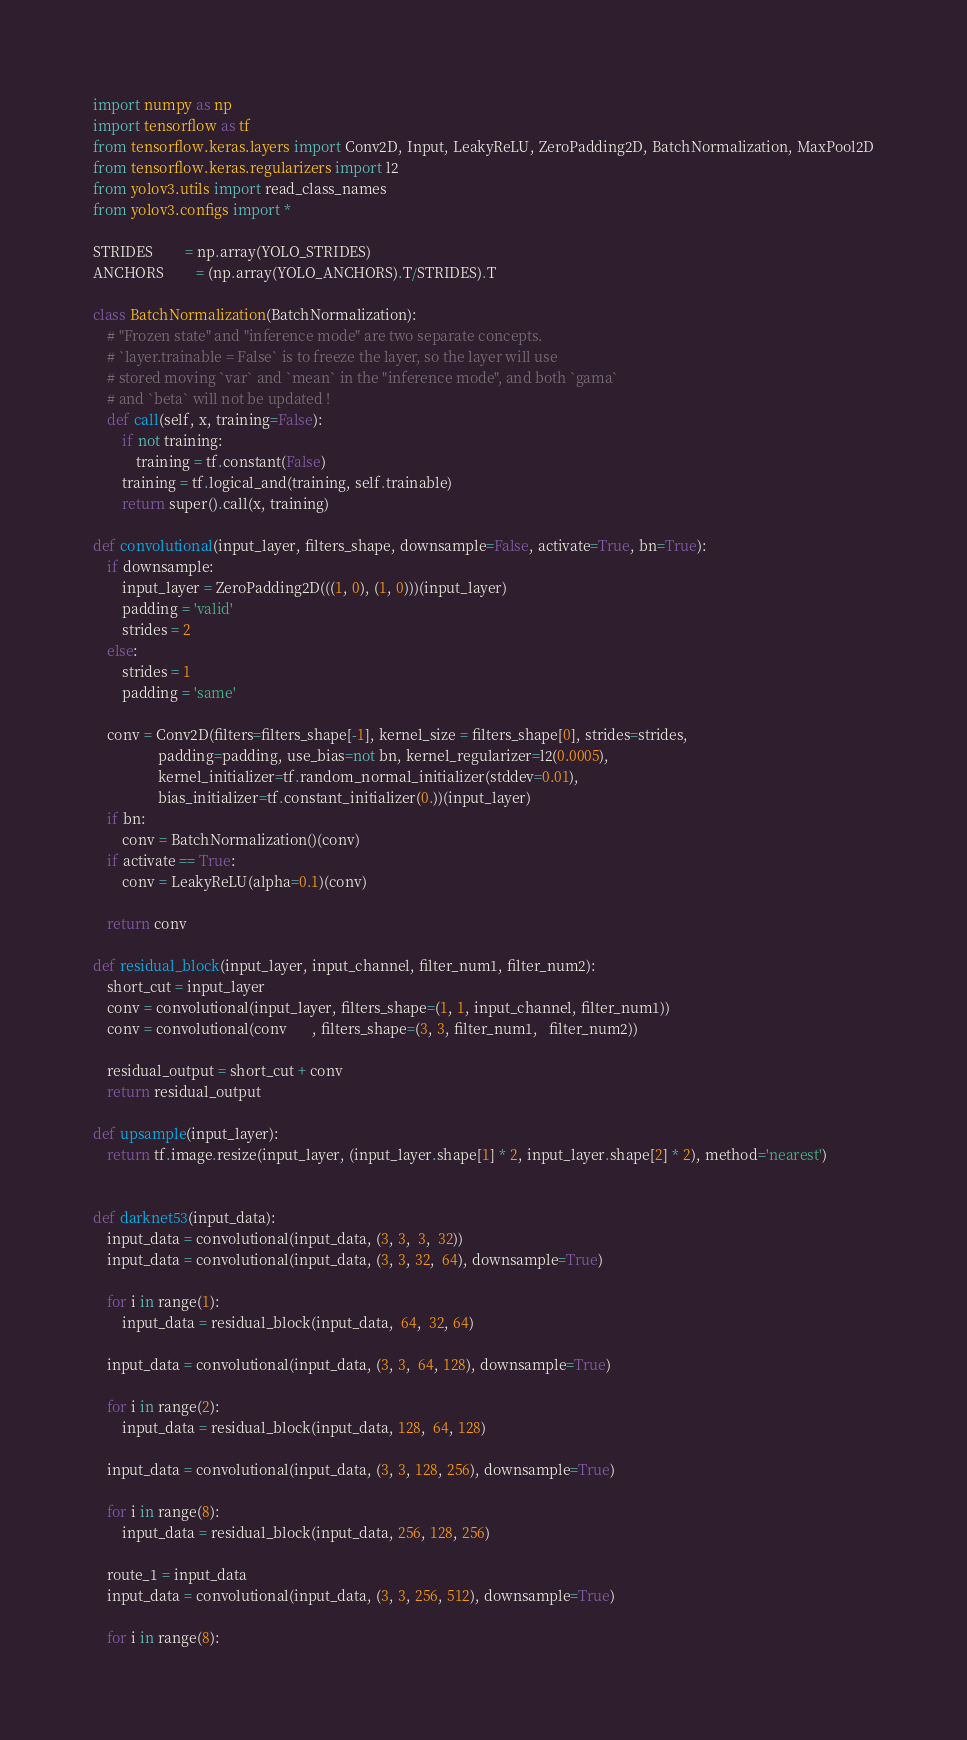Convert code to text. <code><loc_0><loc_0><loc_500><loc_500><_Python_>
import numpy as np
import tensorflow as tf
from tensorflow.keras.layers import Conv2D, Input, LeakyReLU, ZeroPadding2D, BatchNormalization, MaxPool2D
from tensorflow.keras.regularizers import l2
from yolov3.utils import read_class_names
from yolov3.configs import *

STRIDES         = np.array(YOLO_STRIDES)
ANCHORS         = (np.array(YOLO_ANCHORS).T/STRIDES).T

class BatchNormalization(BatchNormalization):
    # "Frozen state" and "inference mode" are two separate concepts.
    # `layer.trainable = False` is to freeze the layer, so the layer will use
    # stored moving `var` and `mean` in the "inference mode", and both `gama`
    # and `beta` will not be updated !
    def call(self, x, training=False):
        if not training:
            training = tf.constant(False)
        training = tf.logical_and(training, self.trainable)
        return super().call(x, training)

def convolutional(input_layer, filters_shape, downsample=False, activate=True, bn=True):
    if downsample:
        input_layer = ZeroPadding2D(((1, 0), (1, 0)))(input_layer)
        padding = 'valid'
        strides = 2
    else:
        strides = 1
        padding = 'same'

    conv = Conv2D(filters=filters_shape[-1], kernel_size = filters_shape[0], strides=strides,
                  padding=padding, use_bias=not bn, kernel_regularizer=l2(0.0005),
                  kernel_initializer=tf.random_normal_initializer(stddev=0.01),
                  bias_initializer=tf.constant_initializer(0.))(input_layer)
    if bn:
        conv = BatchNormalization()(conv)
    if activate == True:
        conv = LeakyReLU(alpha=0.1)(conv)

    return conv

def residual_block(input_layer, input_channel, filter_num1, filter_num2):
    short_cut = input_layer
    conv = convolutional(input_layer, filters_shape=(1, 1, input_channel, filter_num1))
    conv = convolutional(conv       , filters_shape=(3, 3, filter_num1,   filter_num2))

    residual_output = short_cut + conv
    return residual_output

def upsample(input_layer):
    return tf.image.resize(input_layer, (input_layer.shape[1] * 2, input_layer.shape[2] * 2), method='nearest')


def darknet53(input_data):
    input_data = convolutional(input_data, (3, 3,  3,  32))
    input_data = convolutional(input_data, (3, 3, 32,  64), downsample=True)

    for i in range(1):
        input_data = residual_block(input_data,  64,  32, 64)

    input_data = convolutional(input_data, (3, 3,  64, 128), downsample=True)

    for i in range(2):
        input_data = residual_block(input_data, 128,  64, 128)

    input_data = convolutional(input_data, (3, 3, 128, 256), downsample=True)

    for i in range(8):
        input_data = residual_block(input_data, 256, 128, 256)

    route_1 = input_data
    input_data = convolutional(input_data, (3, 3, 256, 512), downsample=True)

    for i in range(8):</code> 